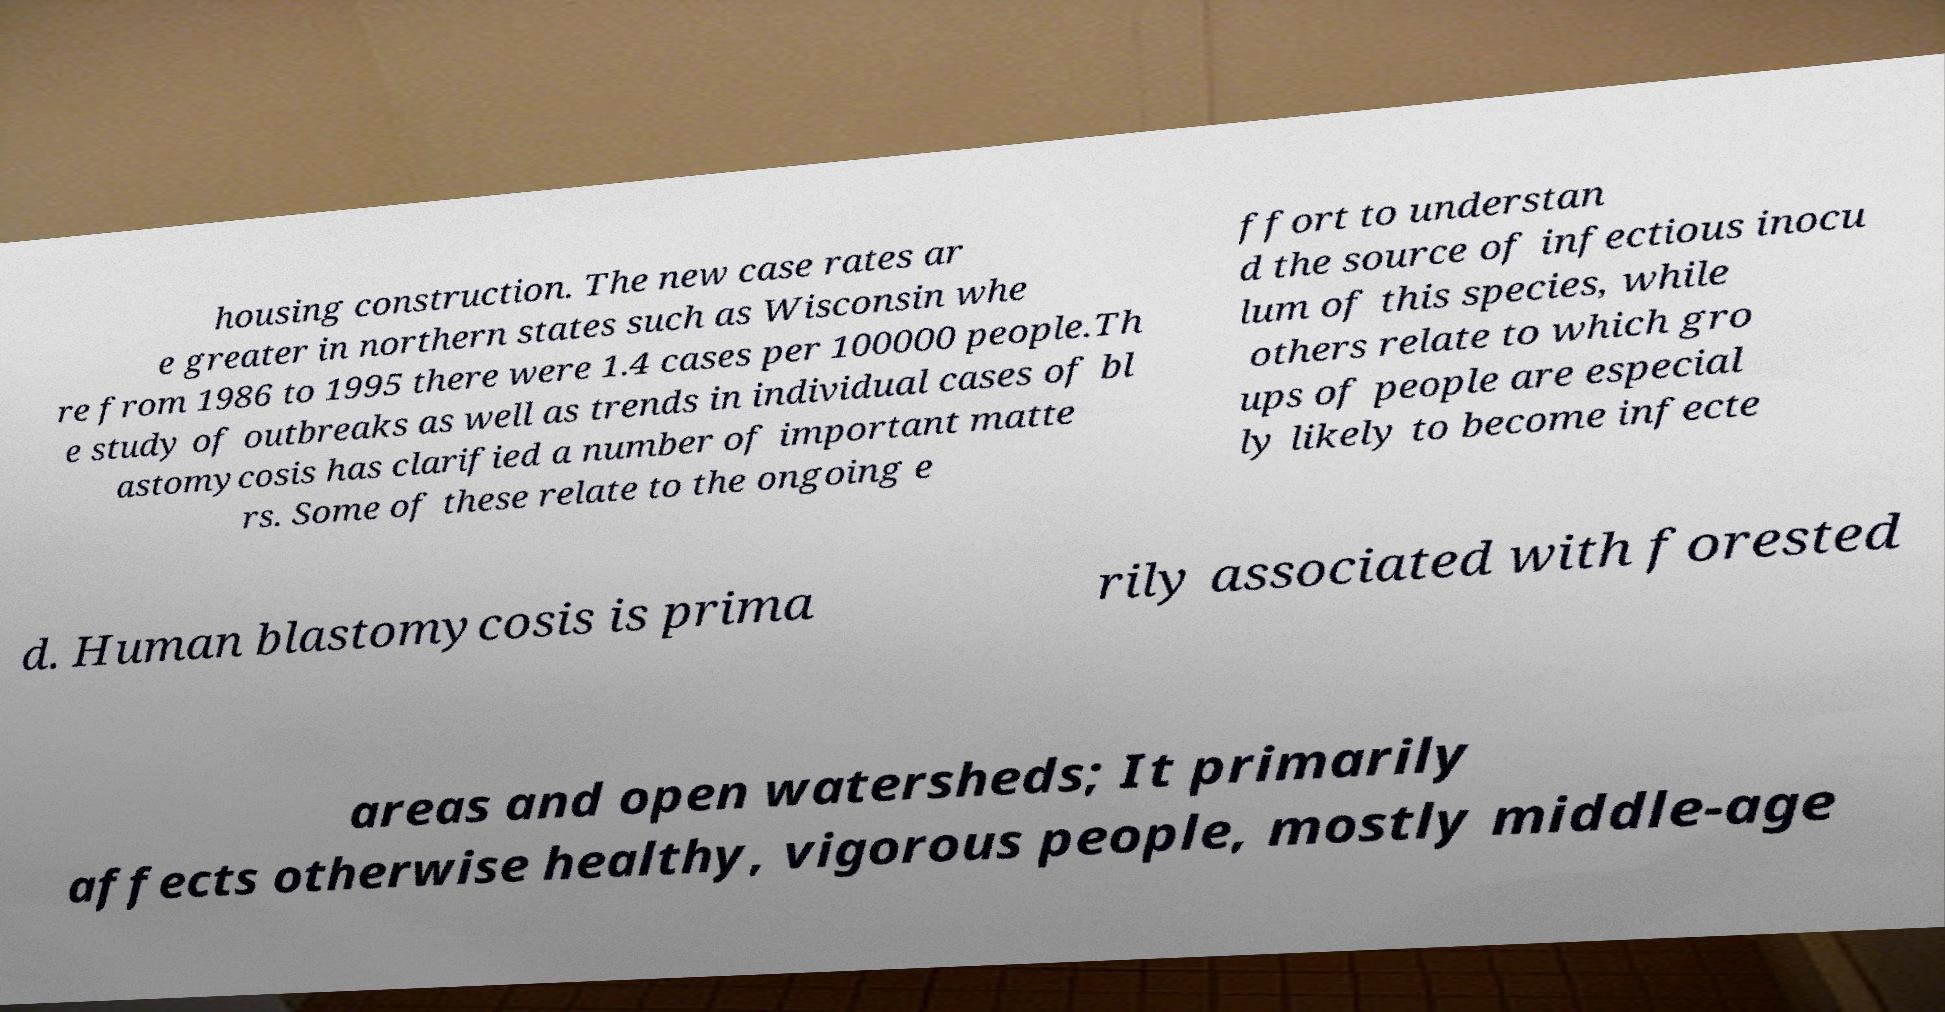Can you accurately transcribe the text from the provided image for me? housing construction. The new case rates ar e greater in northern states such as Wisconsin whe re from 1986 to 1995 there were 1.4 cases per 100000 people.Th e study of outbreaks as well as trends in individual cases of bl astomycosis has clarified a number of important matte rs. Some of these relate to the ongoing e ffort to understan d the source of infectious inocu lum of this species, while others relate to which gro ups of people are especial ly likely to become infecte d. Human blastomycosis is prima rily associated with forested areas and open watersheds; It primarily affects otherwise healthy, vigorous people, mostly middle-age 